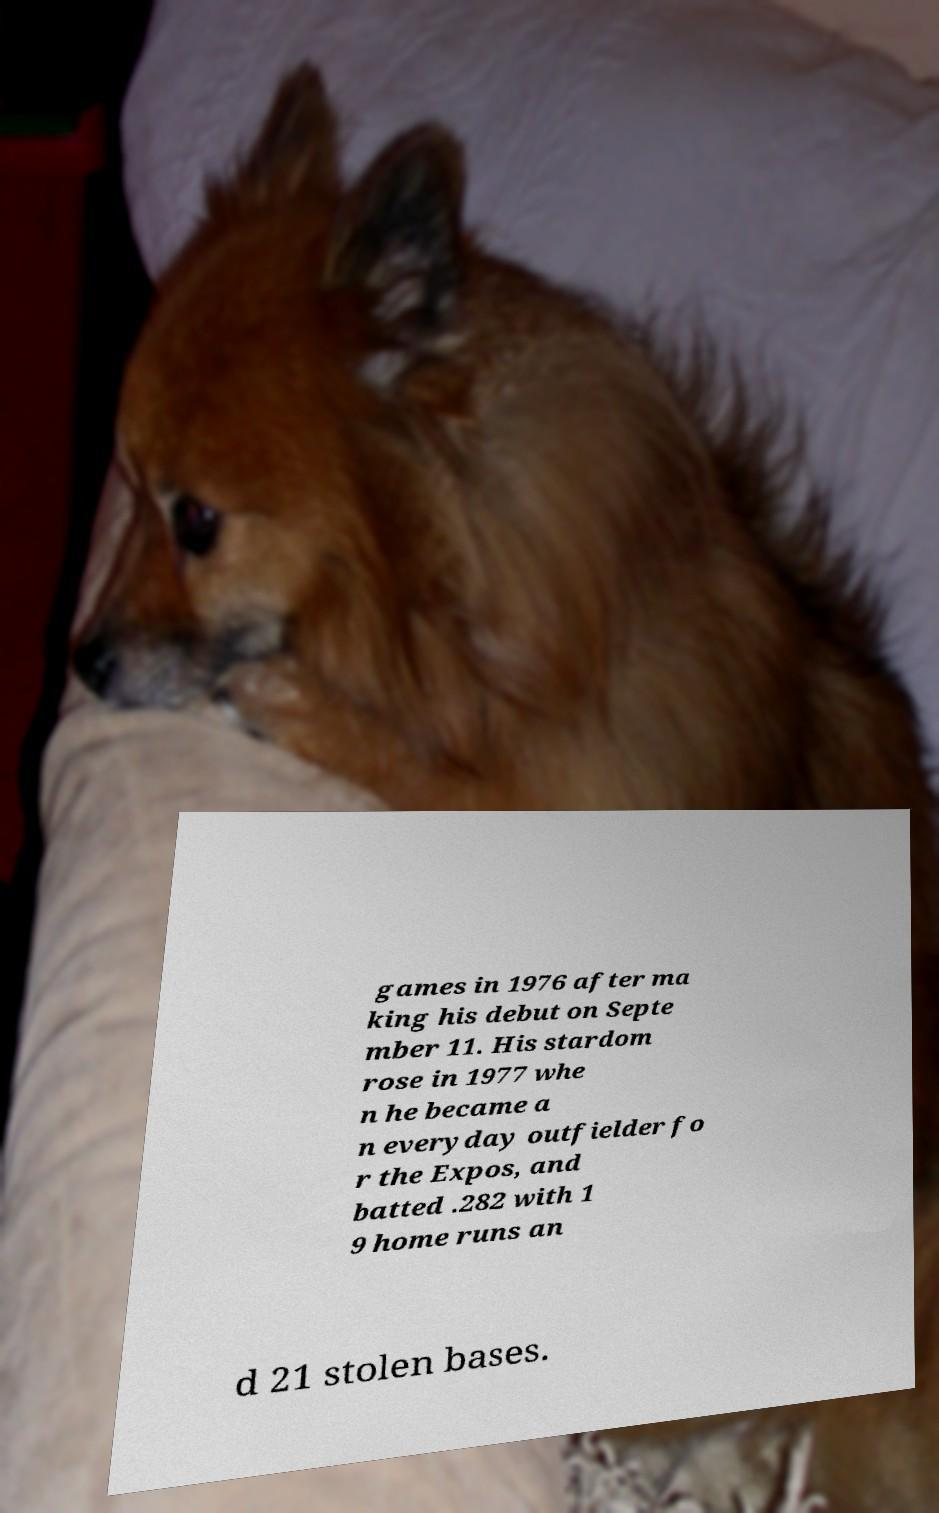What messages or text are displayed in this image? I need them in a readable, typed format. games in 1976 after ma king his debut on Septe mber 11. His stardom rose in 1977 whe n he became a n everyday outfielder fo r the Expos, and batted .282 with 1 9 home runs an d 21 stolen bases. 